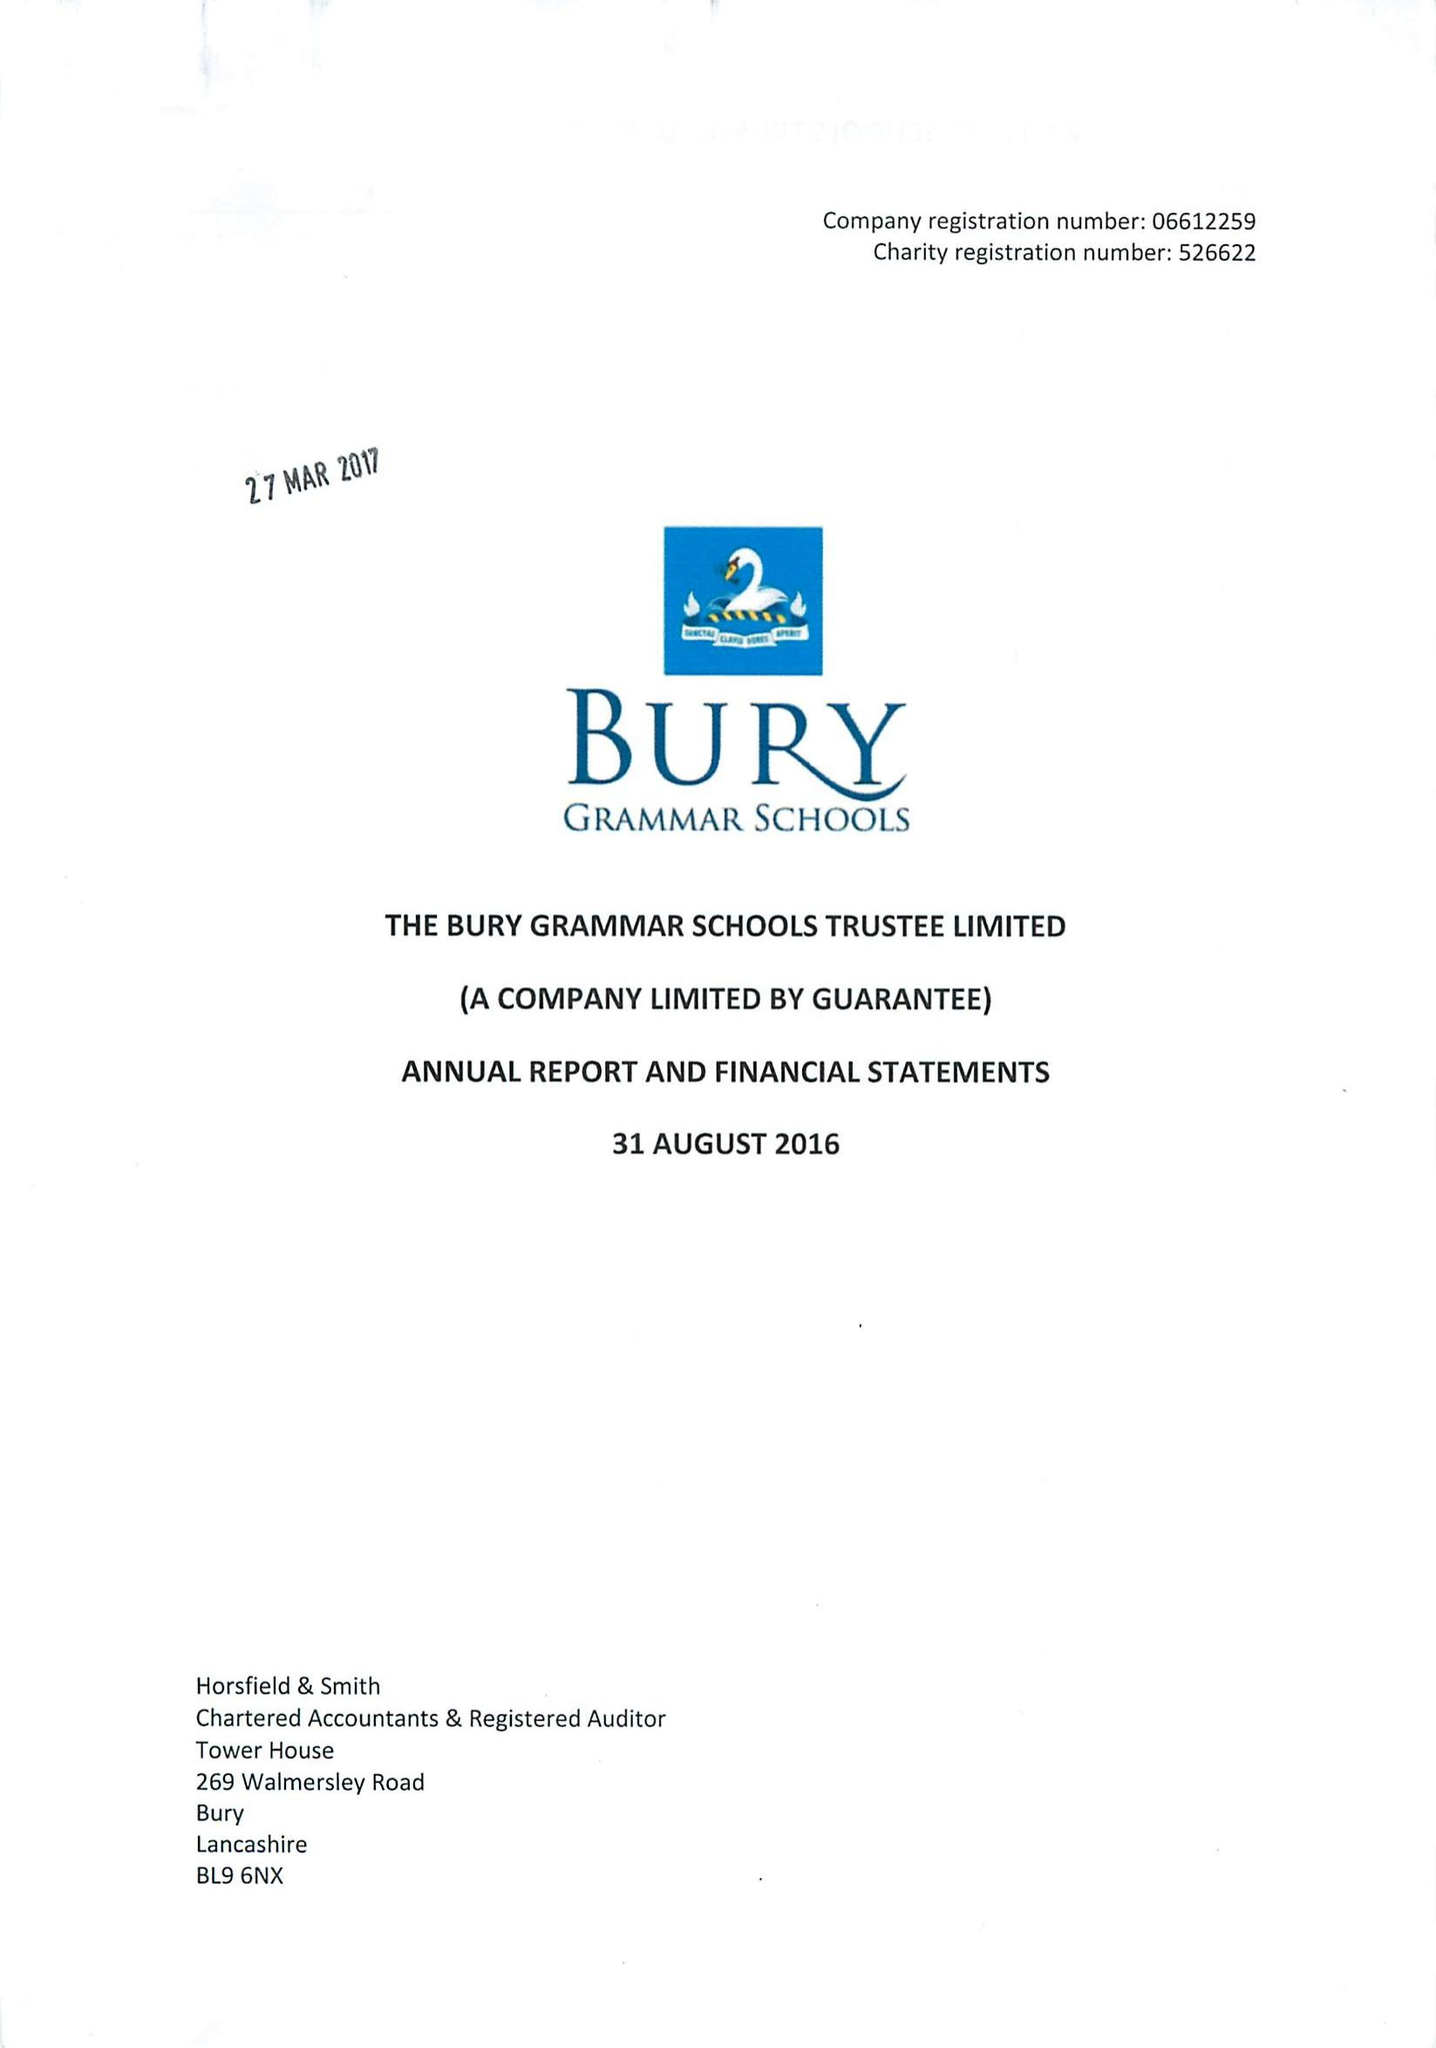What is the value for the report_date?
Answer the question using a single word or phrase. 2016-08-31 